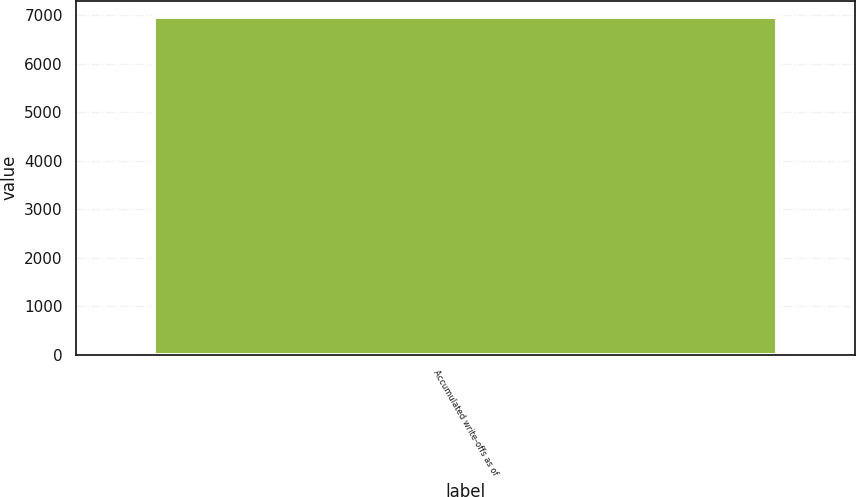<chart> <loc_0><loc_0><loc_500><loc_500><bar_chart><fcel>Accumulated write-offs as of<nl><fcel>6960.2<nl></chart> 